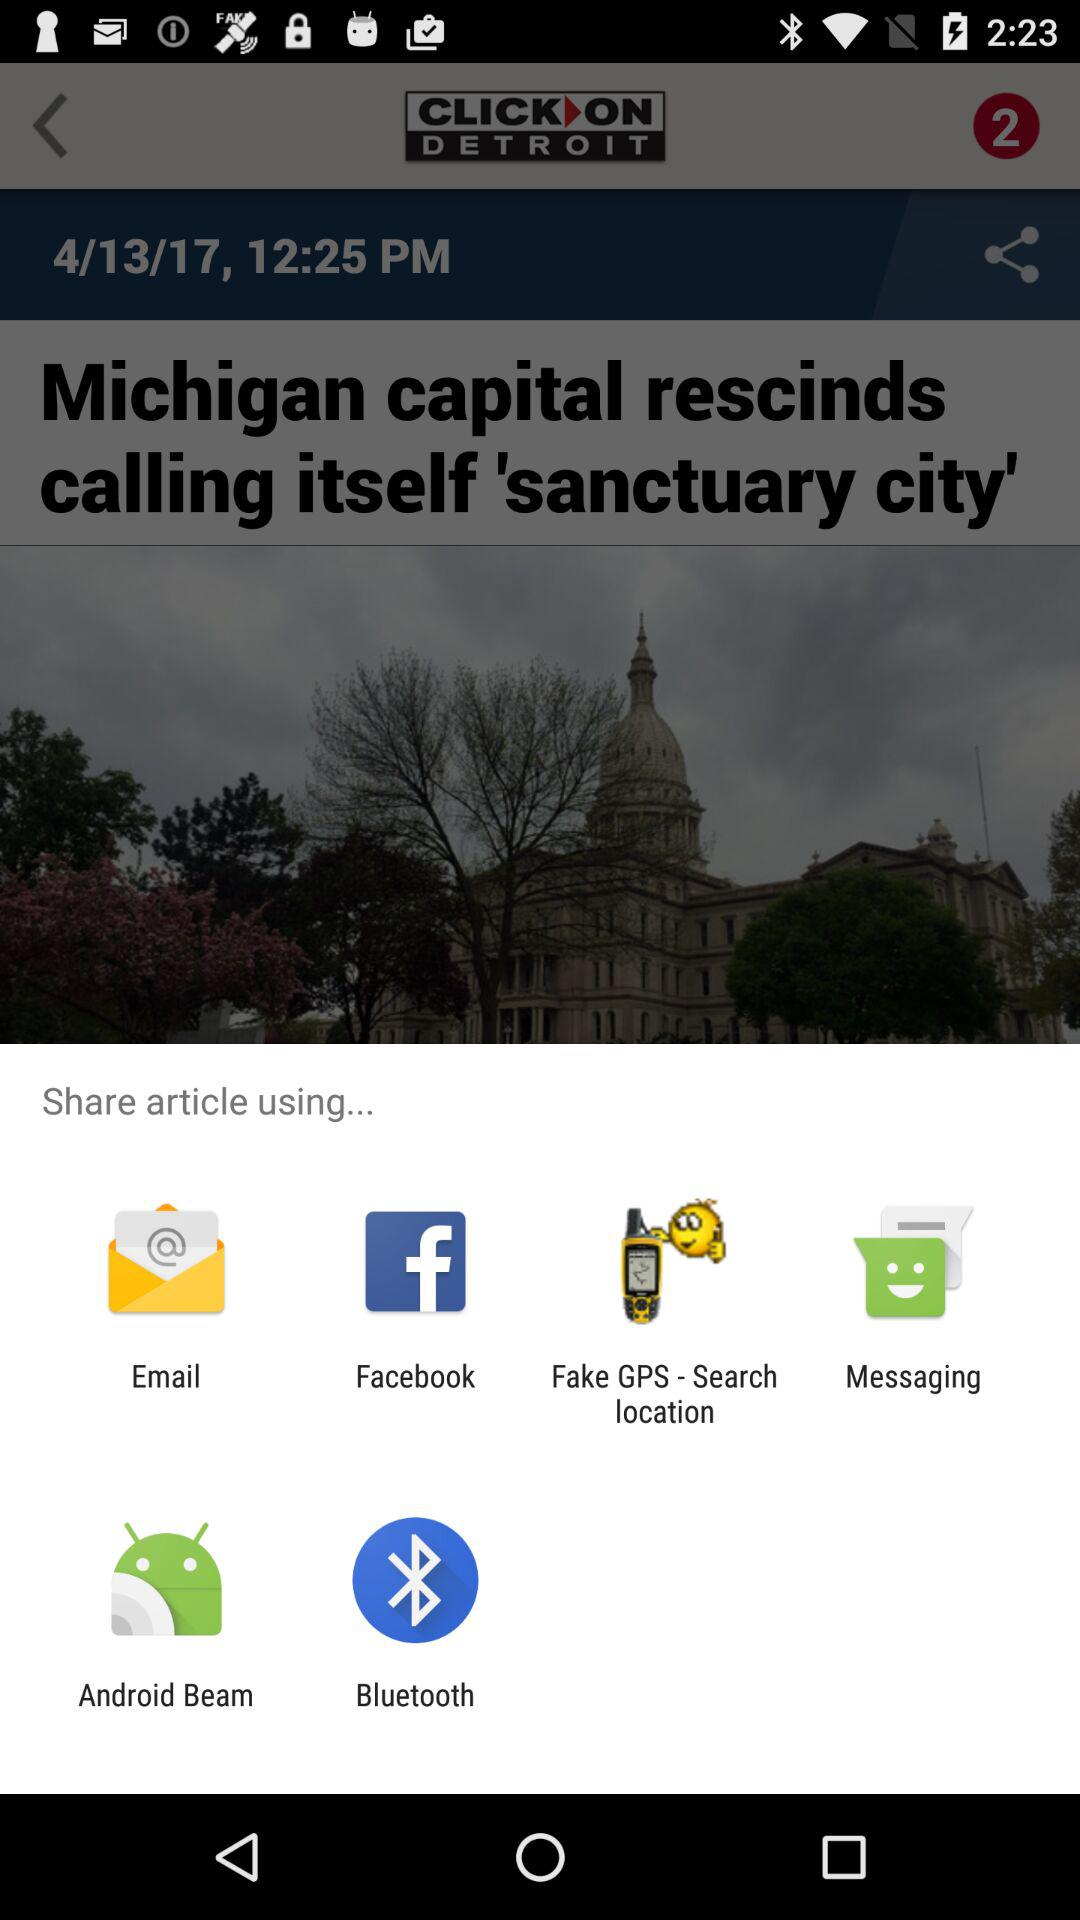Through which applications can we share the article? You can share the article through "Email", "Facebook", "Fake GPS - Search location", "Messaging", "Android Beam" and "Bluetooth". 